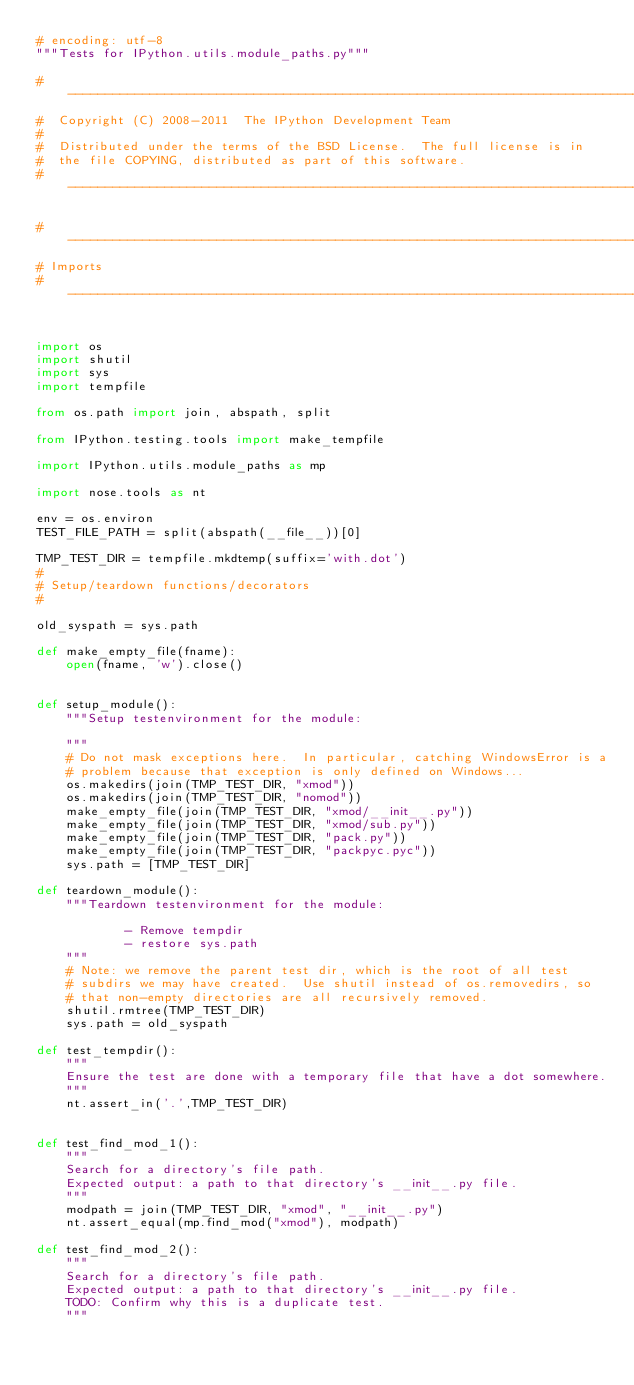Convert code to text. <code><loc_0><loc_0><loc_500><loc_500><_Python_># encoding: utf-8
"""Tests for IPython.utils.module_paths.py"""

#-----------------------------------------------------------------------------
#  Copyright (C) 2008-2011  The IPython Development Team
#
#  Distributed under the terms of the BSD License.  The full license is in
#  the file COPYING, distributed as part of this software.
#-----------------------------------------------------------------------------

#-----------------------------------------------------------------------------
# Imports
#-----------------------------------------------------------------------------


import os
import shutil
import sys
import tempfile

from os.path import join, abspath, split

from IPython.testing.tools import make_tempfile

import IPython.utils.module_paths as mp

import nose.tools as nt

env = os.environ
TEST_FILE_PATH = split(abspath(__file__))[0]

TMP_TEST_DIR = tempfile.mkdtemp(suffix='with.dot')
#
# Setup/teardown functions/decorators
#

old_syspath = sys.path

def make_empty_file(fname):
    open(fname, 'w').close()


def setup_module():
    """Setup testenvironment for the module:

    """
    # Do not mask exceptions here.  In particular, catching WindowsError is a
    # problem because that exception is only defined on Windows...
    os.makedirs(join(TMP_TEST_DIR, "xmod"))
    os.makedirs(join(TMP_TEST_DIR, "nomod"))
    make_empty_file(join(TMP_TEST_DIR, "xmod/__init__.py"))
    make_empty_file(join(TMP_TEST_DIR, "xmod/sub.py"))
    make_empty_file(join(TMP_TEST_DIR, "pack.py"))
    make_empty_file(join(TMP_TEST_DIR, "packpyc.pyc"))
    sys.path = [TMP_TEST_DIR]

def teardown_module():
    """Teardown testenvironment for the module:

            - Remove tempdir
            - restore sys.path
    """
    # Note: we remove the parent test dir, which is the root of all test
    # subdirs we may have created.  Use shutil instead of os.removedirs, so
    # that non-empty directories are all recursively removed.
    shutil.rmtree(TMP_TEST_DIR)
    sys.path = old_syspath

def test_tempdir():
    """
    Ensure the test are done with a temporary file that have a dot somewhere.
    """
    nt.assert_in('.',TMP_TEST_DIR)


def test_find_mod_1():
    """
    Search for a directory's file path.
    Expected output: a path to that directory's __init__.py file.
    """
    modpath = join(TMP_TEST_DIR, "xmod", "__init__.py")
    nt.assert_equal(mp.find_mod("xmod"), modpath)

def test_find_mod_2():
    """
    Search for a directory's file path.
    Expected output: a path to that directory's __init__.py file.
    TODO: Confirm why this is a duplicate test.
    """</code> 